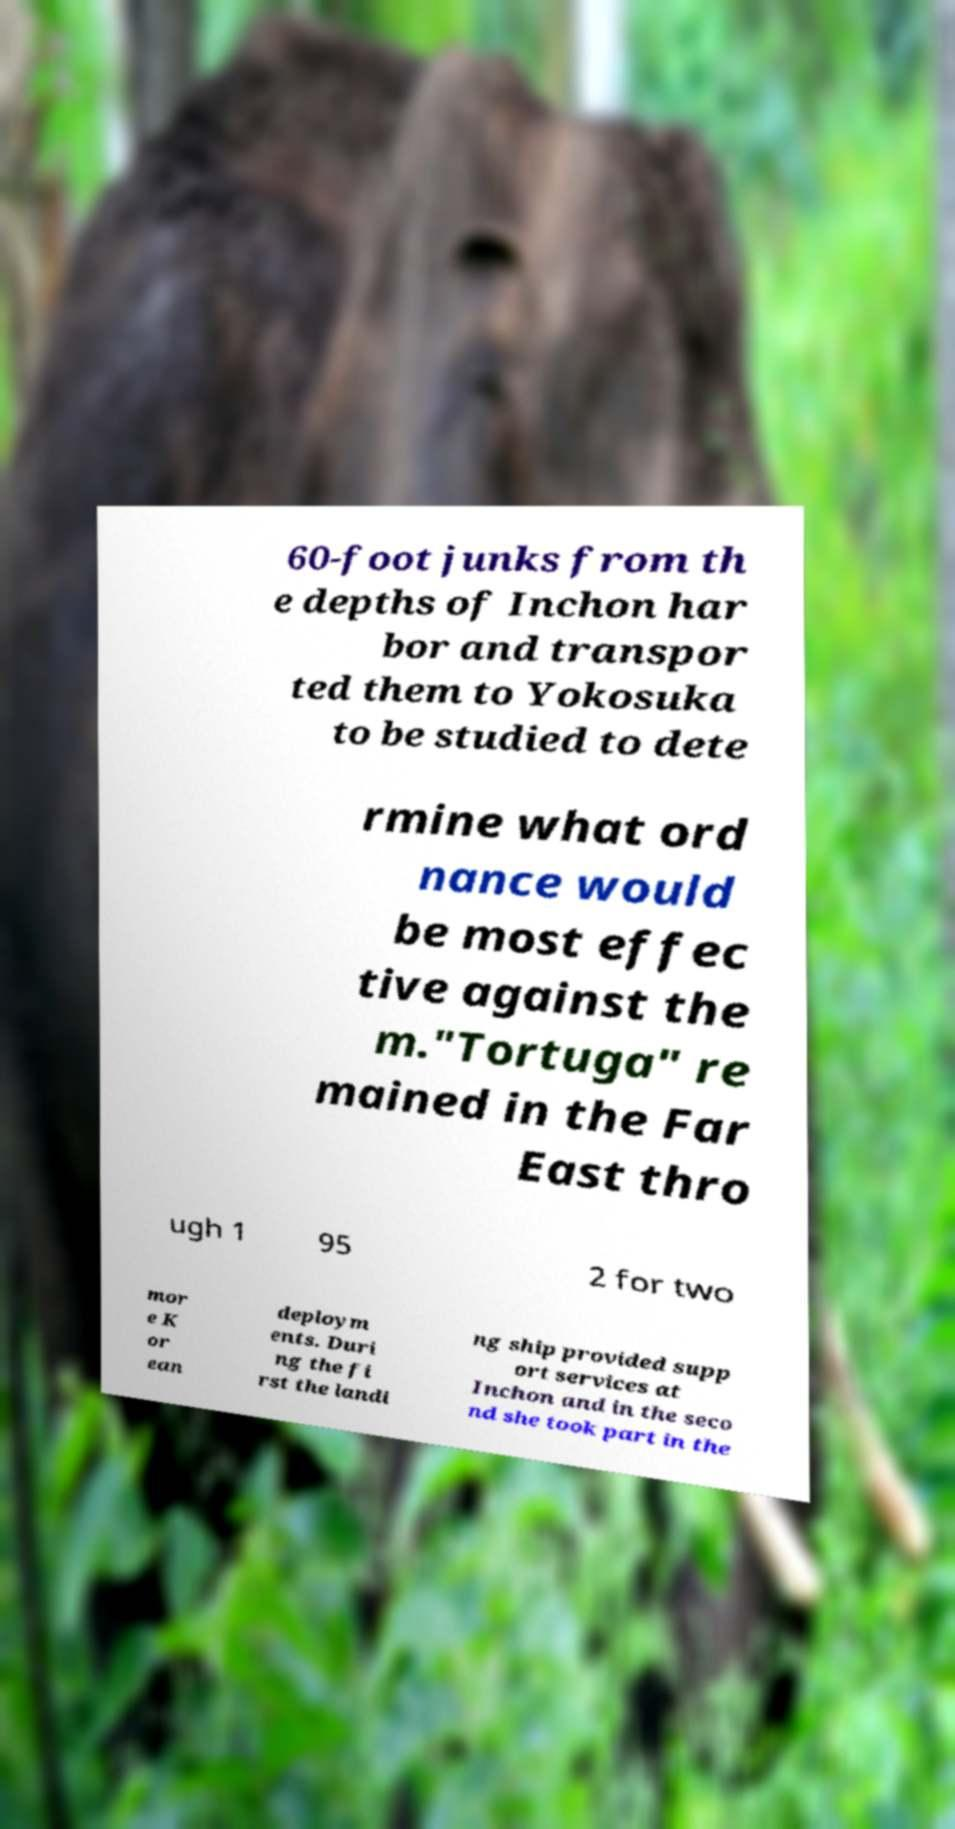What messages or text are displayed in this image? I need them in a readable, typed format. 60-foot junks from th e depths of Inchon har bor and transpor ted them to Yokosuka to be studied to dete rmine what ord nance would be most effec tive against the m."Tortuga" re mained in the Far East thro ugh 1 95 2 for two mor e K or ean deploym ents. Duri ng the fi rst the landi ng ship provided supp ort services at Inchon and in the seco nd she took part in the 